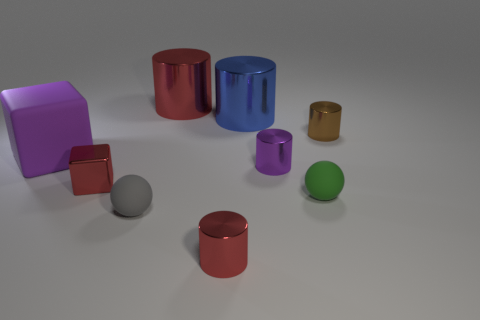Subtract 2 cylinders. How many cylinders are left? 3 Subtract all purple cylinders. How many cylinders are left? 4 Subtract all blue cylinders. How many cylinders are left? 4 Subtract all gray cylinders. Subtract all yellow balls. How many cylinders are left? 5 Subtract all balls. How many objects are left? 7 Subtract 0 purple spheres. How many objects are left? 9 Subtract all small red cylinders. Subtract all large gray matte things. How many objects are left? 8 Add 5 blue metal things. How many blue metal things are left? 6 Add 8 spheres. How many spheres exist? 10 